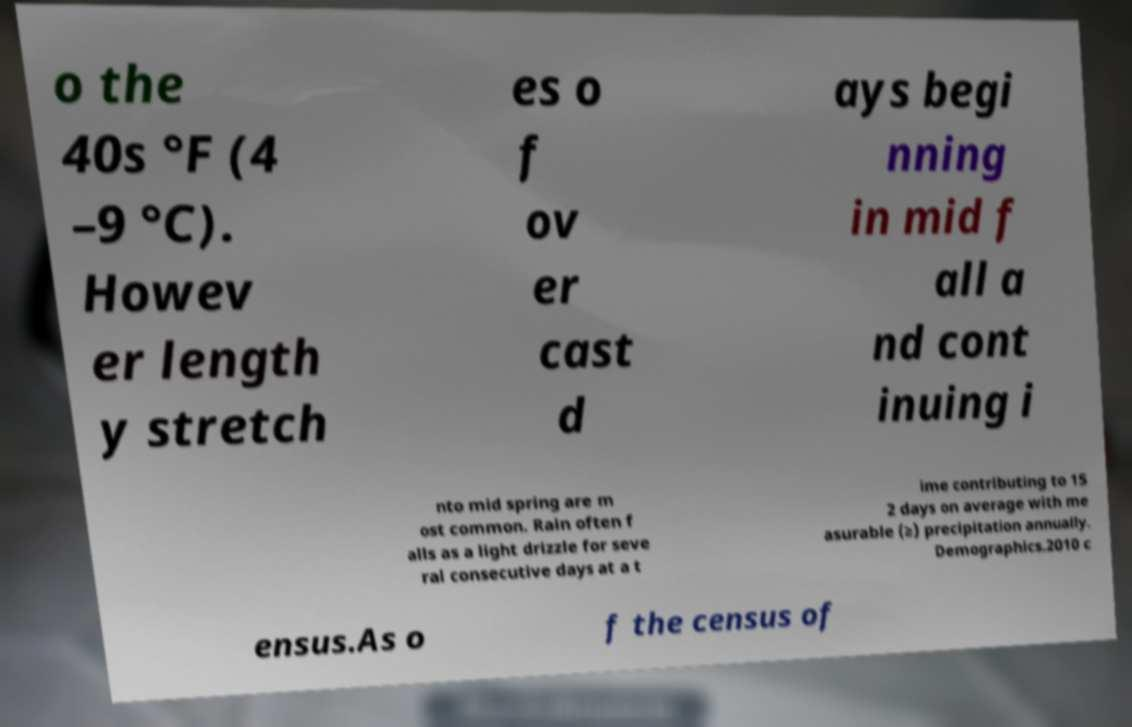Can you read and provide the text displayed in the image?This photo seems to have some interesting text. Can you extract and type it out for me? o the 40s °F (4 –9 °C). Howev er length y stretch es o f ov er cast d ays begi nning in mid f all a nd cont inuing i nto mid spring are m ost common. Rain often f alls as a light drizzle for seve ral consecutive days at a t ime contributing to 15 2 days on average with me asurable (≥) precipitation annually. Demographics.2010 c ensus.As o f the census of 